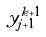Convert formula to latex. <formula><loc_0><loc_0><loc_500><loc_500>y _ { j + 1 } ^ { k + 1 }</formula> 